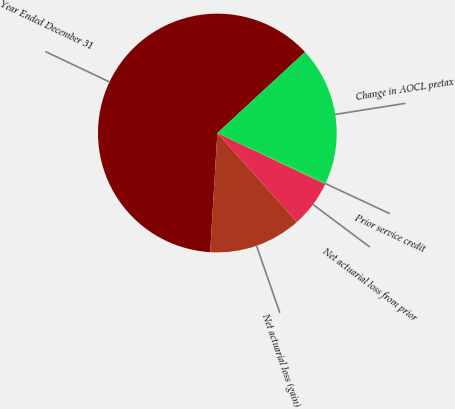Convert chart. <chart><loc_0><loc_0><loc_500><loc_500><pie_chart><fcel>Year Ended December 31<fcel>Net actuarial loss (gain)<fcel>Net actuarial loss from prior<fcel>Prior service credit<fcel>Change in AOCL pretax<nl><fcel>62.17%<fcel>12.56%<fcel>6.36%<fcel>0.15%<fcel>18.76%<nl></chart> 